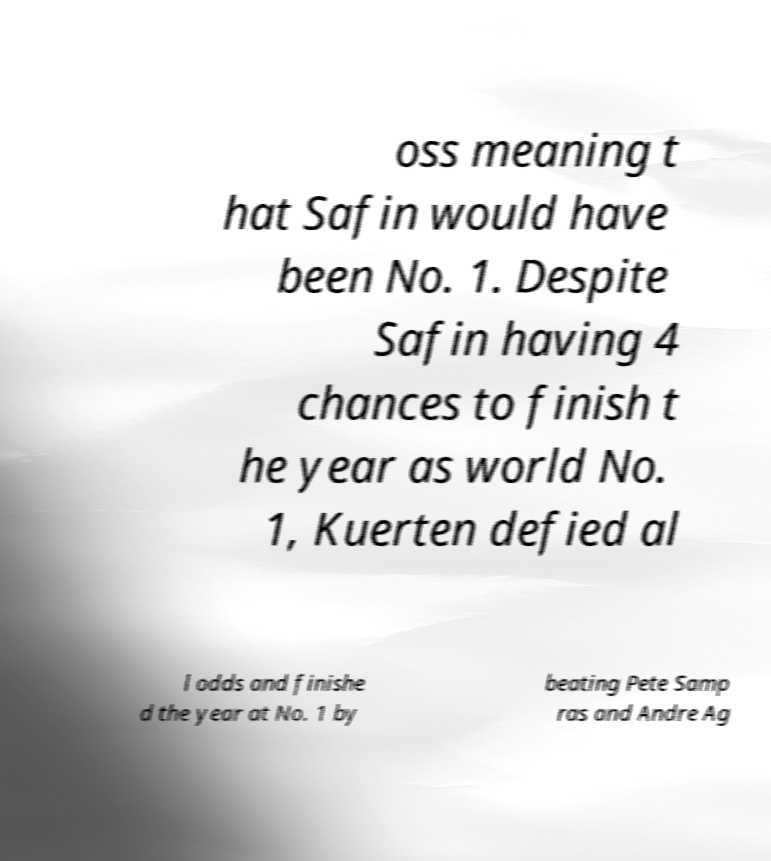I need the written content from this picture converted into text. Can you do that? oss meaning t hat Safin would have been No. 1. Despite Safin having 4 chances to finish t he year as world No. 1, Kuerten defied al l odds and finishe d the year at No. 1 by beating Pete Samp ras and Andre Ag 